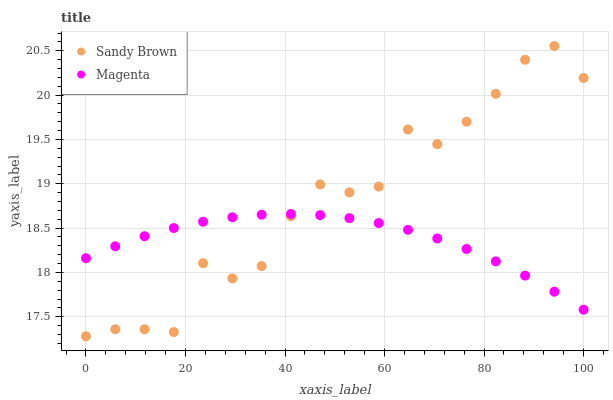Does Magenta have the minimum area under the curve?
Answer yes or no. Yes. Does Sandy Brown have the maximum area under the curve?
Answer yes or no. Yes. Does Sandy Brown have the minimum area under the curve?
Answer yes or no. No. Is Magenta the smoothest?
Answer yes or no. Yes. Is Sandy Brown the roughest?
Answer yes or no. Yes. Is Sandy Brown the smoothest?
Answer yes or no. No. Does Sandy Brown have the lowest value?
Answer yes or no. Yes. Does Sandy Brown have the highest value?
Answer yes or no. Yes. Does Magenta intersect Sandy Brown?
Answer yes or no. Yes. Is Magenta less than Sandy Brown?
Answer yes or no. No. Is Magenta greater than Sandy Brown?
Answer yes or no. No. 